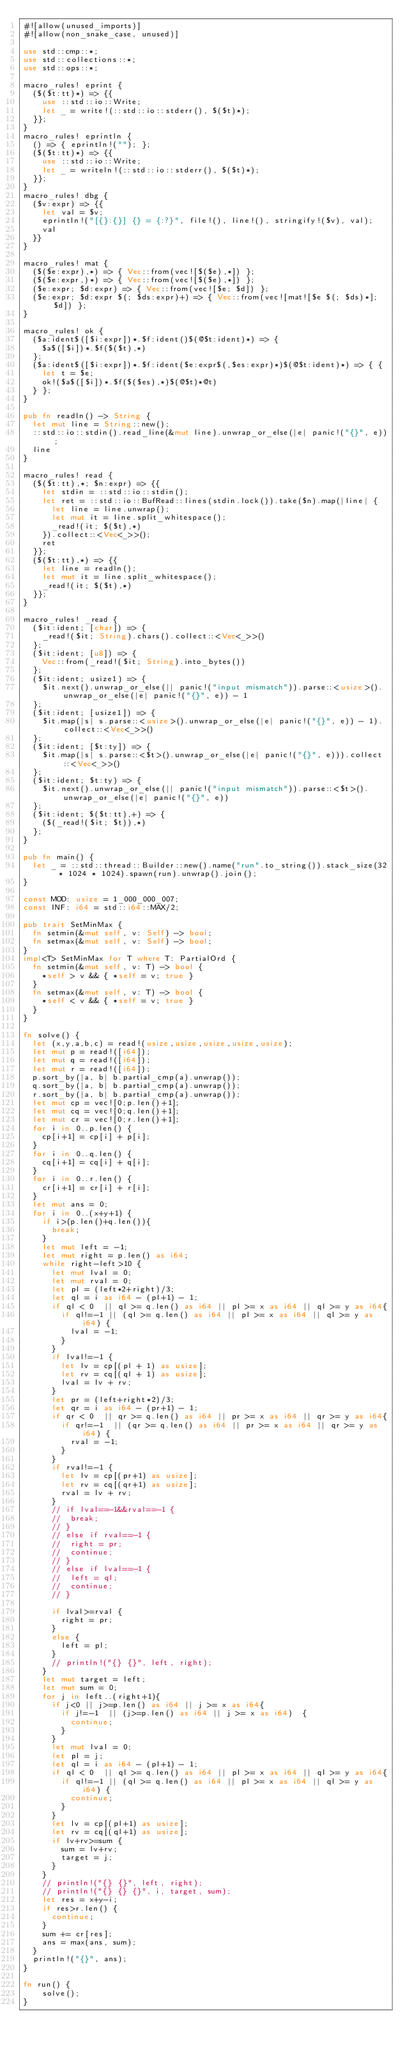<code> <loc_0><loc_0><loc_500><loc_500><_Rust_>#![allow(unused_imports)]
#![allow(non_snake_case, unused)]

use std::cmp::*;
use std::collections::*;
use std::ops::*;

macro_rules! eprint {
	($($t:tt)*) => {{
		use ::std::io::Write;
		let _ = write!(::std::io::stderr(), $($t)*);
	}};
}
macro_rules! eprintln {
	() => { eprintln!(""); };
	($($t:tt)*) => {{
		use ::std::io::Write;
		let _ = writeln!(::std::io::stderr(), $($t)*);
	}};
}
macro_rules! dbg {
	($v:expr) => {{
		let val = $v;
		eprintln!("[{}:{}] {} = {:?}", file!(), line!(), stringify!($v), val);
		val
	}}
}

macro_rules! mat {
	($($e:expr),*) => { Vec::from(vec![$($e),*]) };
	($($e:expr,)*) => { Vec::from(vec![$($e),*]) };
	($e:expr; $d:expr) => { Vec::from(vec![$e; $d]) };
	($e:expr; $d:expr $(; $ds:expr)+) => { Vec::from(vec![mat![$e $(; $ds)*]; $d]) };
}

macro_rules! ok {
	($a:ident$([$i:expr])*.$f:ident()$(@$t:ident)*) => {
		$a$([$i])*.$f($($t),*)
	};
	($a:ident$([$i:expr])*.$f:ident($e:expr$(,$es:expr)*)$(@$t:ident)*) => { {
		let t = $e;
		ok!($a$([$i])*.$f($($es),*)$(@$t)*@t)
	} };
}

pub fn readln() -> String {
	let mut line = String::new();
	::std::io::stdin().read_line(&mut line).unwrap_or_else(|e| panic!("{}", e));
	line
}

macro_rules! read {
	($($t:tt),*; $n:expr) => {{
		let stdin = ::std::io::stdin();
		let ret = ::std::io::BufRead::lines(stdin.lock()).take($n).map(|line| {
			let line = line.unwrap();
			let mut it = line.split_whitespace();
			_read!(it; $($t),*)
		}).collect::<Vec<_>>();
		ret
	}};
	($($t:tt),*) => {{
		let line = readln();
		let mut it = line.split_whitespace();
		_read!(it; $($t),*)
	}};
}

macro_rules! _read {
	($it:ident; [char]) => {
		_read!($it; String).chars().collect::<Vec<_>>()
	};
	($it:ident; [u8]) => {
		Vec::from(_read!($it; String).into_bytes())
	};
	($it:ident; usize1) => {
		$it.next().unwrap_or_else(|| panic!("input mismatch")).parse::<usize>().unwrap_or_else(|e| panic!("{}", e)) - 1
	};
	($it:ident; [usize1]) => {
		$it.map(|s| s.parse::<usize>().unwrap_or_else(|e| panic!("{}", e)) - 1).collect::<Vec<_>>()
	};
	($it:ident; [$t:ty]) => {
		$it.map(|s| s.parse::<$t>().unwrap_or_else(|e| panic!("{}", e))).collect::<Vec<_>>()
	};
	($it:ident; $t:ty) => {
		$it.next().unwrap_or_else(|| panic!("input mismatch")).parse::<$t>().unwrap_or_else(|e| panic!("{}", e))
	};
	($it:ident; $($t:tt),+) => {
		($(_read!($it; $t)),*)
	};
}

pub fn main() {
	let _ = ::std::thread::Builder::new().name("run".to_string()).stack_size(32 * 1024 * 1024).spawn(run).unwrap().join();
}

const MOD: usize = 1_000_000_007;
const INF: i64 = std::i64::MAX/2;

pub trait SetMinMax {
	fn setmin(&mut self, v: Self) -> bool;
	fn setmax(&mut self, v: Self) -> bool;
}
impl<T> SetMinMax for T where T: PartialOrd {
	fn setmin(&mut self, v: T) -> bool {
		*self > v && { *self = v; true }
	}
	fn setmax(&mut self, v: T) -> bool {
		*self < v && { *self = v; true }
	}
}

fn solve() {
	let (x,y,a,b,c) = read!(usize,usize,usize,usize,usize);
	let mut p = read!([i64]);
	let mut q = read!([i64]);
	let mut r = read!([i64]);
	p.sort_by(|a, b| b.partial_cmp(a).unwrap());
	q.sort_by(|a, b| b.partial_cmp(a).unwrap());
	r.sort_by(|a, b| b.partial_cmp(a).unwrap());
	let mut cp = vec![0;p.len()+1];	
	let mut cq = vec![0;q.len()+1];	
	let mut cr = vec![0;r.len()+1];	
	for i in 0..p.len() {
		cp[i+1] = cp[i] + p[i];
	}
	for i in 0..q.len() {
		cq[i+1] = cq[i] + q[i];
	}
	for i in 0..r.len() {
		cr[i+1] = cr[i] + r[i];
	}
	let mut ans = 0;
	for i in 0..(x+y+1) {
		if i>(p.len()+q.len()){
			break;
		}
		let mut left = -1;
		let mut right = p.len() as i64;
		while right-left>10 {
			let mut lval = 0;
			let mut rval = 0;
			let pl = (left*2+right)/3;
			let ql = i as i64 - (pl+1) - 1;
			if ql < 0  || ql >= q.len() as i64 || pl >= x as i64 || ql >= y as i64{
				if ql!=-1 || (ql >= q.len() as i64 || pl >= x as i64 || ql >= y as i64) {
					lval = -1;
				}
			}
			if lval!=-1 {
				let lv = cp[(pl + 1) as usize];
				let rv = cq[(ql + 1) as usize];
				lval = lv + rv;
			}
			let pr = (left+right*2)/3;
			let qr = i as i64 - (pr+1) - 1;
			if qr < 0  || qr >= q.len() as i64 || pr >= x as i64 || qr >= y as i64{
				if qr!=-1  || (qr >= q.len() as i64 || pr >= x as i64 || qr >= y as i64) {
					rval = -1;
				}
			}
			if rval!=-1 {
				let lv = cp[(pr+1) as usize];
				let rv = cq[(qr+1) as usize];
				rval = lv + rv;
			}
			// if lval==-1&&rval==-1 {
			// 	break;
			// }
			// else if rval==-1 {
			// 	right = pr;
			// 	continue;
			// }
			// else if lval==-1 {
			// 	left = ql;
			// 	continue;
			// }

			if lval>=rval {
				right = pr;
			}
			else {
				left = pl;
			}
			// println!("{} {}", left, right);
		}
		let mut target = left;
		let mut sum = 0;
		for j in left..(right+1){
			if j<0 || j>=p.len() as i64 || j >= x as i64{
				if j!=-1  || (j>=p.len() as i64 || j >= x as i64)  {
					continue;
				}
			}
			let mut lval = 0;
			let pl = j;
			let ql = i as i64 - (pl+1) - 1;
			if ql < 0  || ql >= q.len() as i64 || pl >= x as i64 || ql >= y as i64{
				if ql!=-1 || (ql >= q.len() as i64 || pl >= x as i64 || ql >= y as i64) {
					continue;
				}
			}
			let lv = cp[(pl+1) as usize];
			let rv = cq[(ql+1) as usize];
			if lv+rv>=sum {
				sum = lv+rv;
				target = j;
			}
		}
		// println!("{} {}", left, right);
		// println!("{} {} {}", i, target, sum);
		let res = x+y-i;
		if res>r.len() {
			continue;
		}
		sum += cr[res];
		ans = max(ans, sum);
	}
	println!("{}", ans);
}

fn run() {
    solve();
}
</code> 